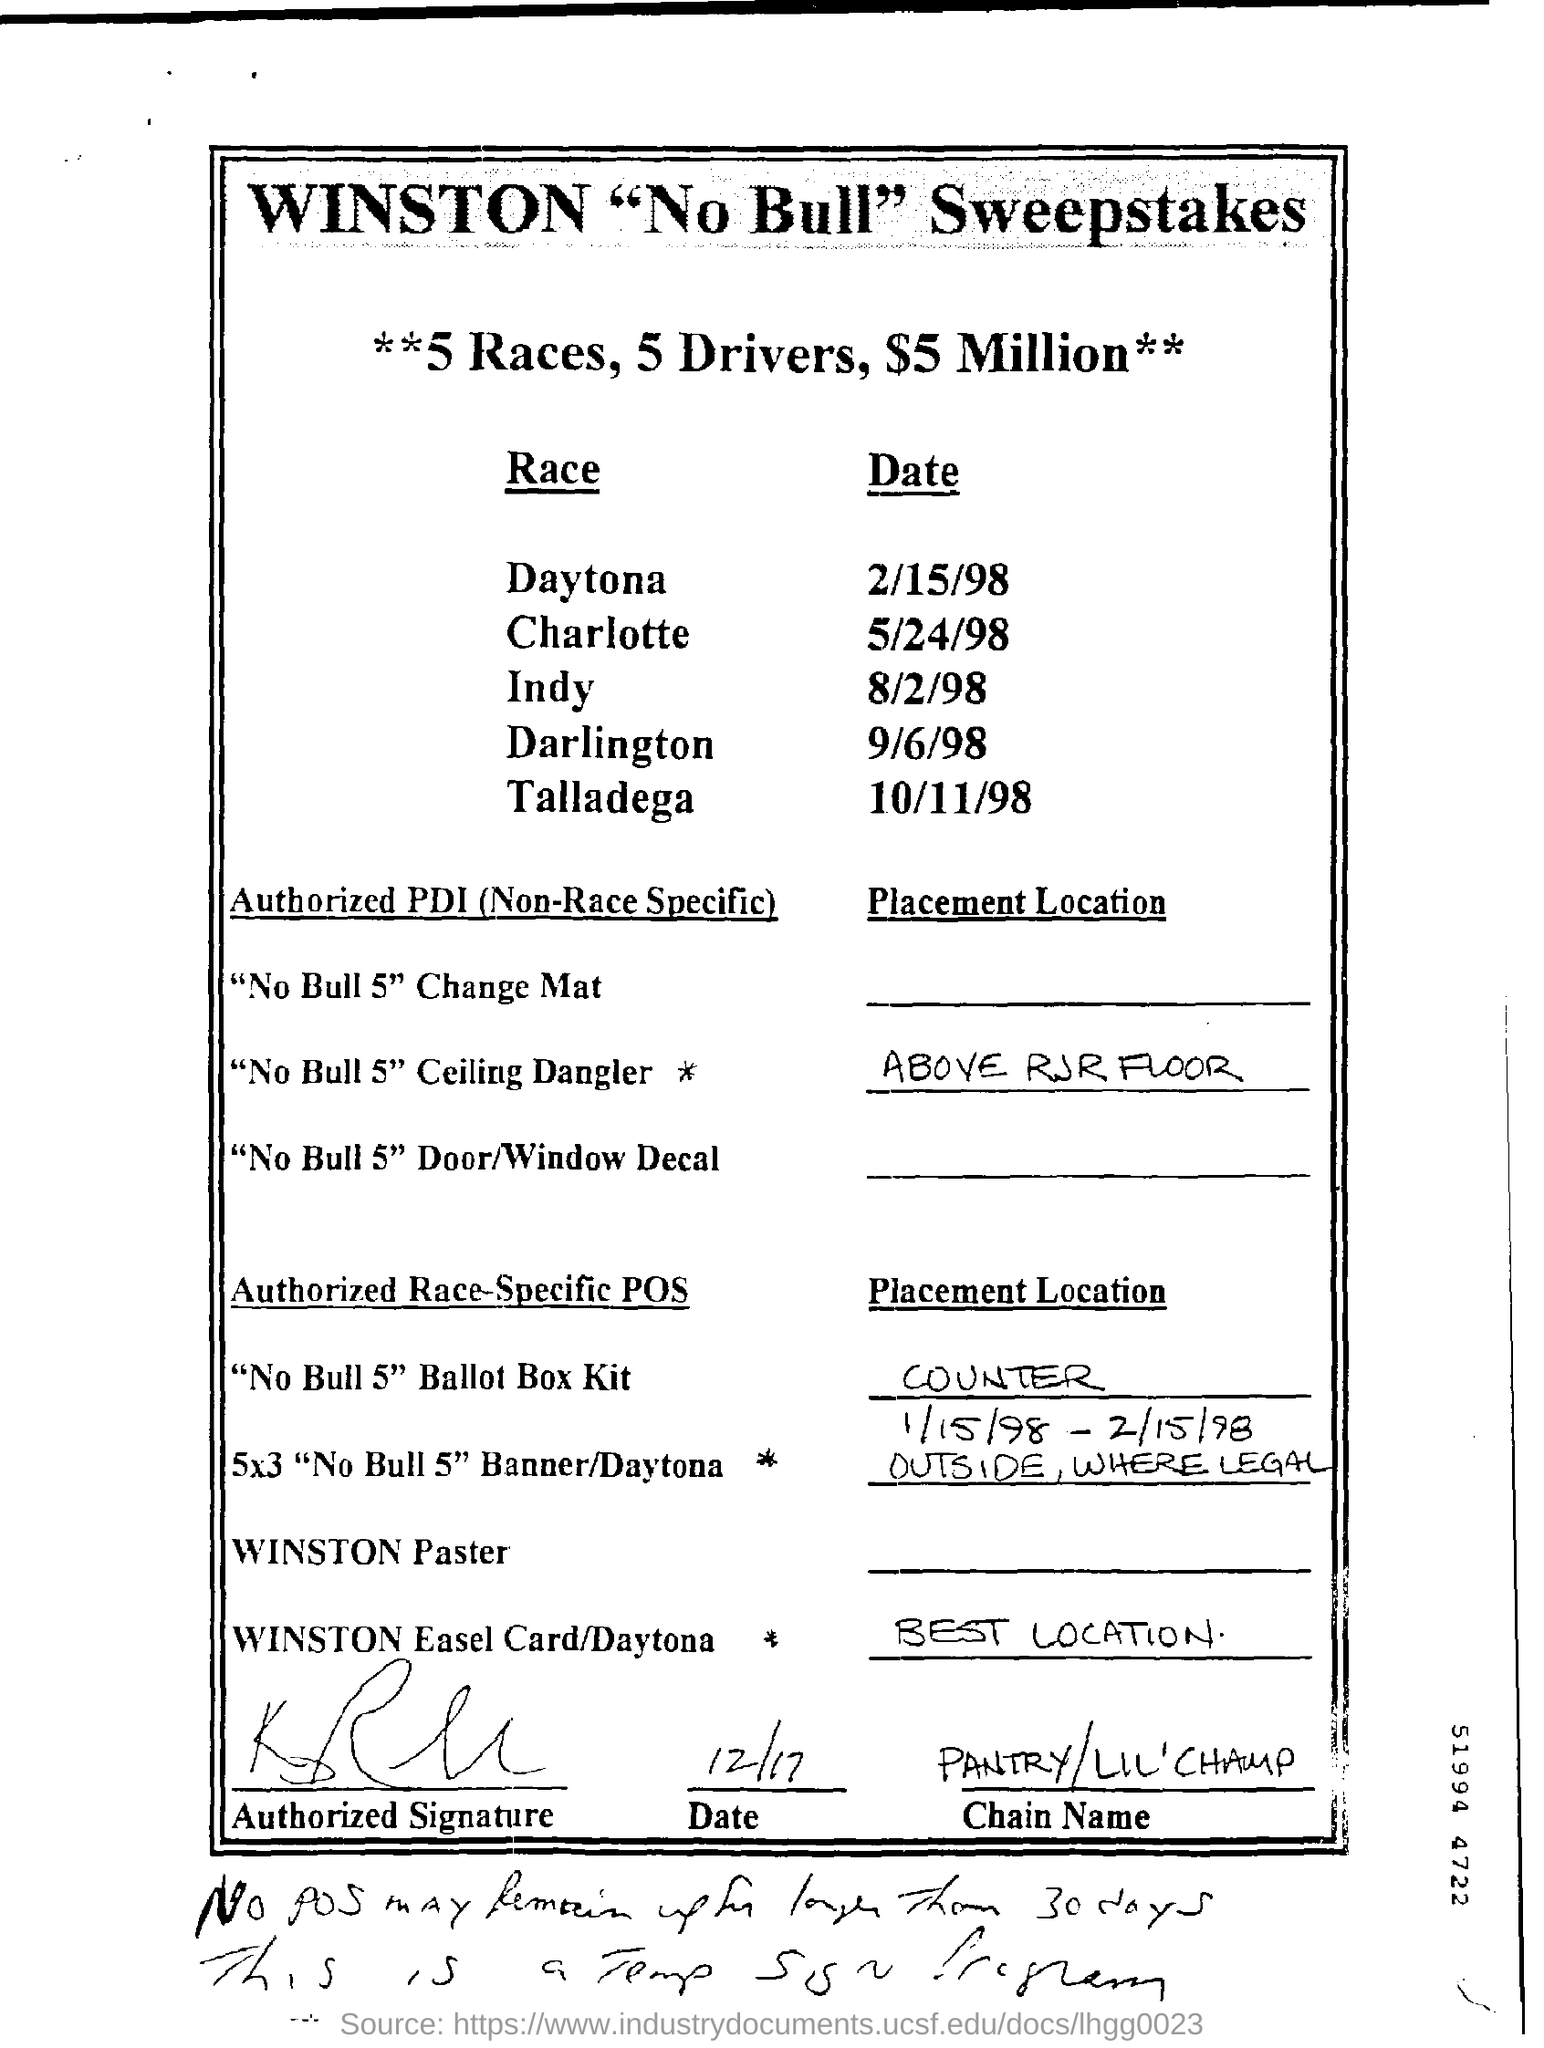How many number of races are mentioned?
Ensure brevity in your answer.  5. How many number of drivers are mentioned?
Your answer should be compact. 5. When is the Indy race held?
Offer a very short reply. 8/2/98. Which race is held on 9/6/98?
Give a very brief answer. Darlington. Which race is held on 10/11/98?
Offer a very short reply. Talladega. Which race is held on 2/15/98?
Offer a very short reply. Daytona. When is the Charlotte race held?
Your answer should be very brief. 5/24/98. 